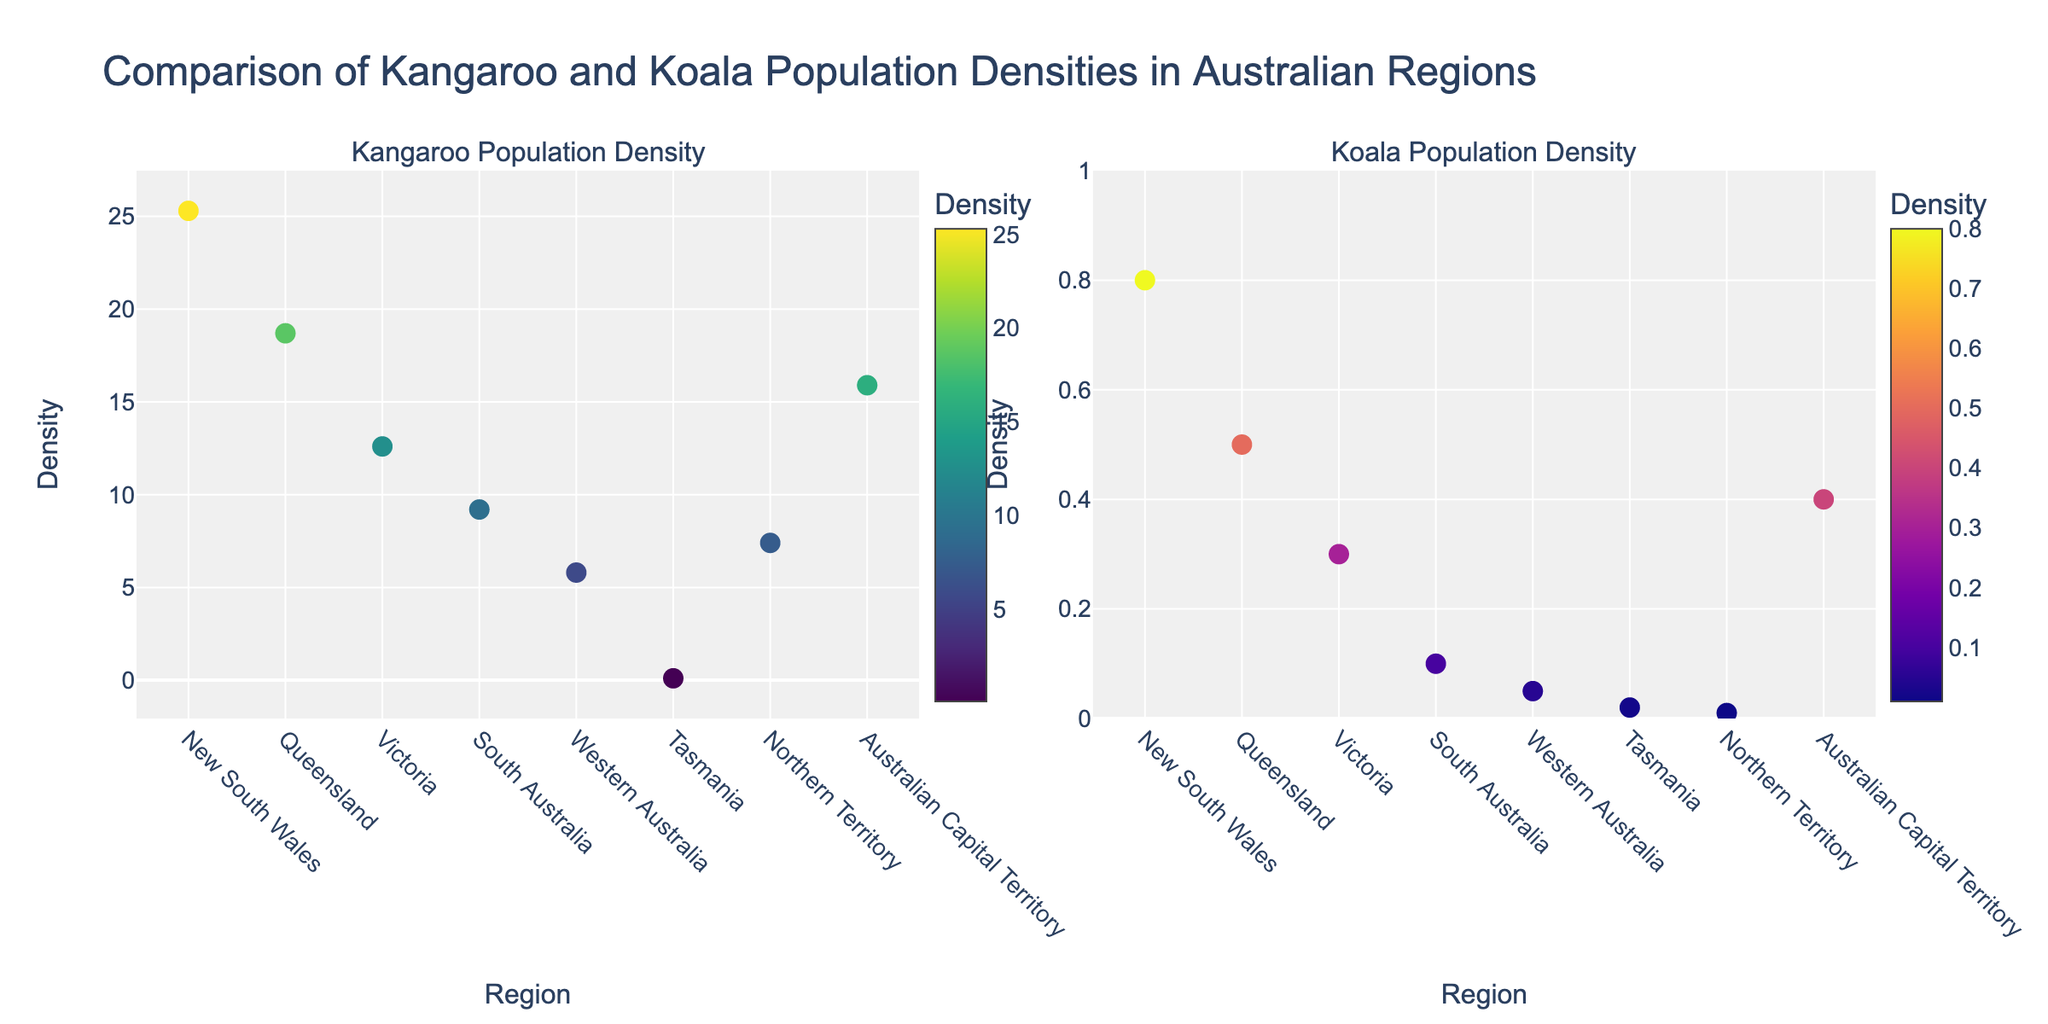What's the title of the figure? The title text is displayed at the top of the figure.
Answer: "Comparison of Kangaroo and Koala Population Densities in Australian Regions" What are the axes labels in the Kangaroo Population Density plot? The x-axis is labeled "Region" and the y-axis is labeled "Density".
Answer: Region, Density How many regions are presented in the Kangaroo Density plot? Each data point represents one region. Count the x-axis labels or data points.
Answer: 8 Which region has the highest kangaroo population density? The region with the highest point on the Kangaroo Density y-axis is the one with the highest population density.
Answer: New South Wales What is the color scale used for the Kangaroo Density markers? The color scale is visible in the legend of the Kangaroo Density plot.
Answer: Viridis What is the density value for koalas in Queensland? Find Queensland on the x-axis of the Koala Density plot and read the corresponding y-axis value.
Answer: 0.5 Which region has the lowest koala population density? The region with the lowest point on the Koala Density y-axis is the one with the lowest population density.
Answer: Northern Territory What is the difference in kangaroo density between Victoria and Western Australia? Find Victoria and Western Australia on the Kangaroo Density plot. Subtract Western Australia's density from Victoria's density.
Answer: 12.6 - 5.8 = 6.8 Which region shows a higher variation in population density between kangaroos and koalas? Compare the difference between kangaroo and koala densities for each region and see which difference is largest.
Answer: New South Wales What's the sum of kangaroo densities across all regions? Add up the kangaroo densities for all regions: 25.3 + 18.7 + 12.6 + 9.2 + 5.8 + 0.1 + 7.4 + 15.9.
Answer: 95 